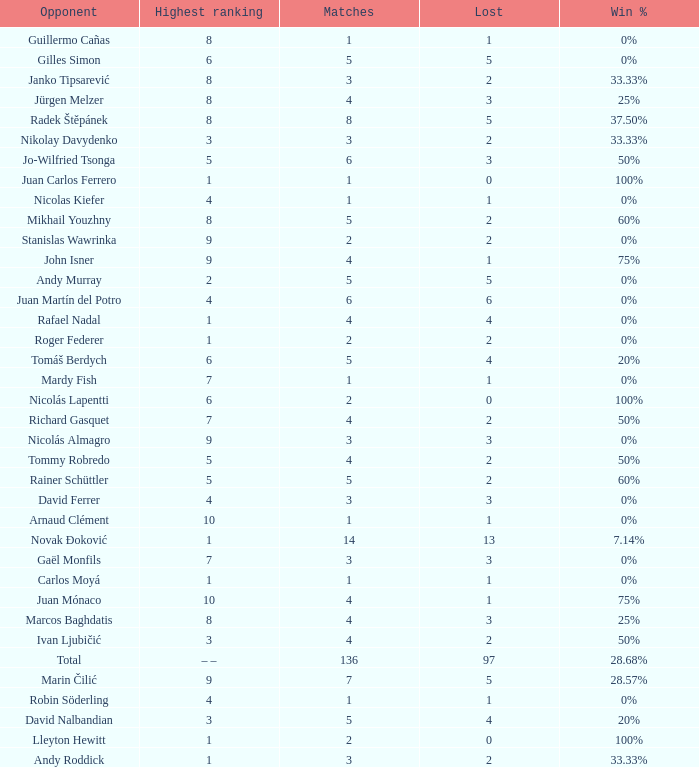What is the total number of Lost for the Highest Ranking of – –? 1.0. 